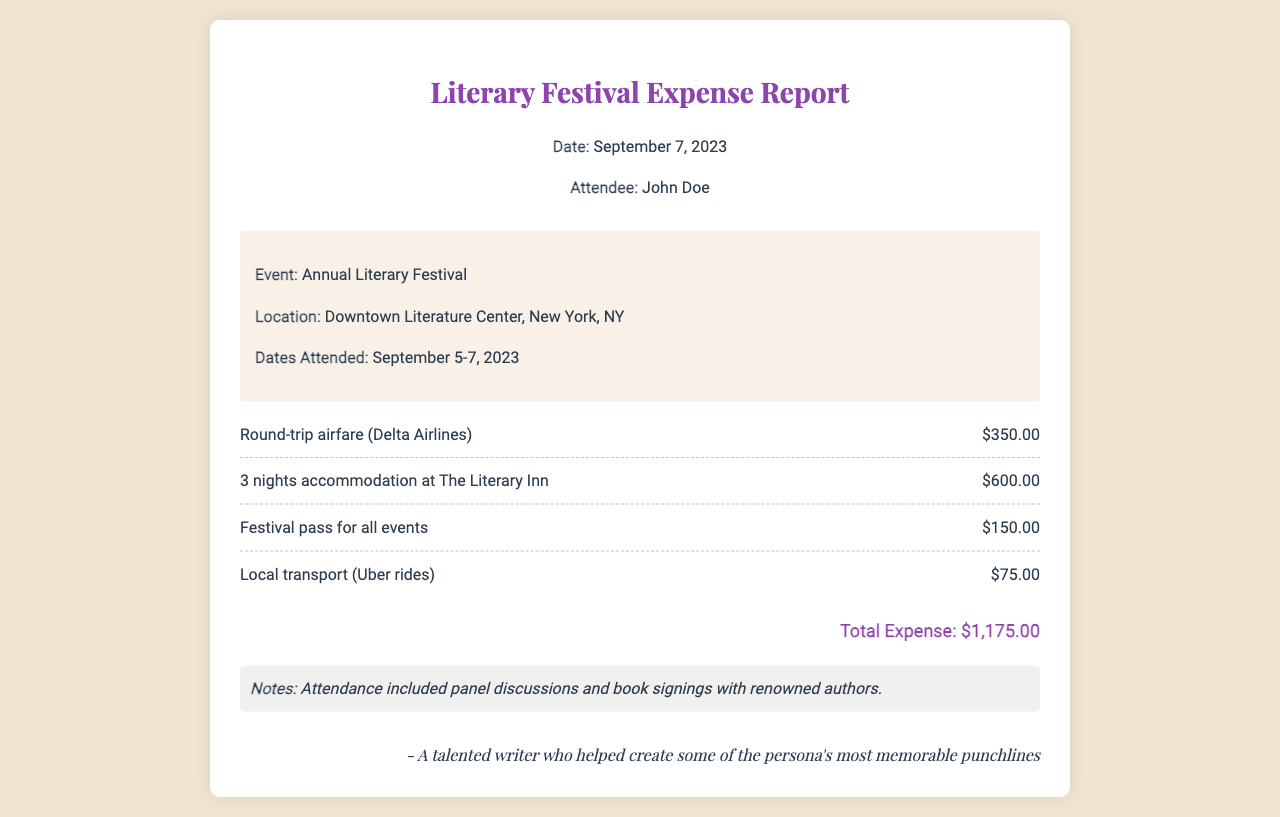What is the total expense? The total expense is the sum of all listed costs in the document, which amounts to $1,175.00.
Answer: $1,175.00 Who is the attendee? The attendee's name is mentioned in the header of the document.
Answer: John Doe When did the event take place? The dates attended are specifically stated in the event details section of the document.
Answer: September 5-7, 2023 What type of transport costs were incurred? The document lists a specific local transport method used during the festival.
Answer: Uber rides How many nights was accommodation booked for? The accommodation duration is provided in the itemized expenses section of the document.
Answer: 3 nights Where was the event held? The document specifies the location of the festival in the event details section.
Answer: Downtown Literature Center, New York, NY What item had the highest cost? The items listed indicate which one incurred the greatest expense.
Answer: Accommodation What was included in the attendance? Additional context about the festival is provided in the notes at the end of the document.
Answer: Panel discussions and book signings with renowned authors What airline was used for travel? The document specifies the airline for the round-trip airfare listed in the expenses.
Answer: Delta Airlines 